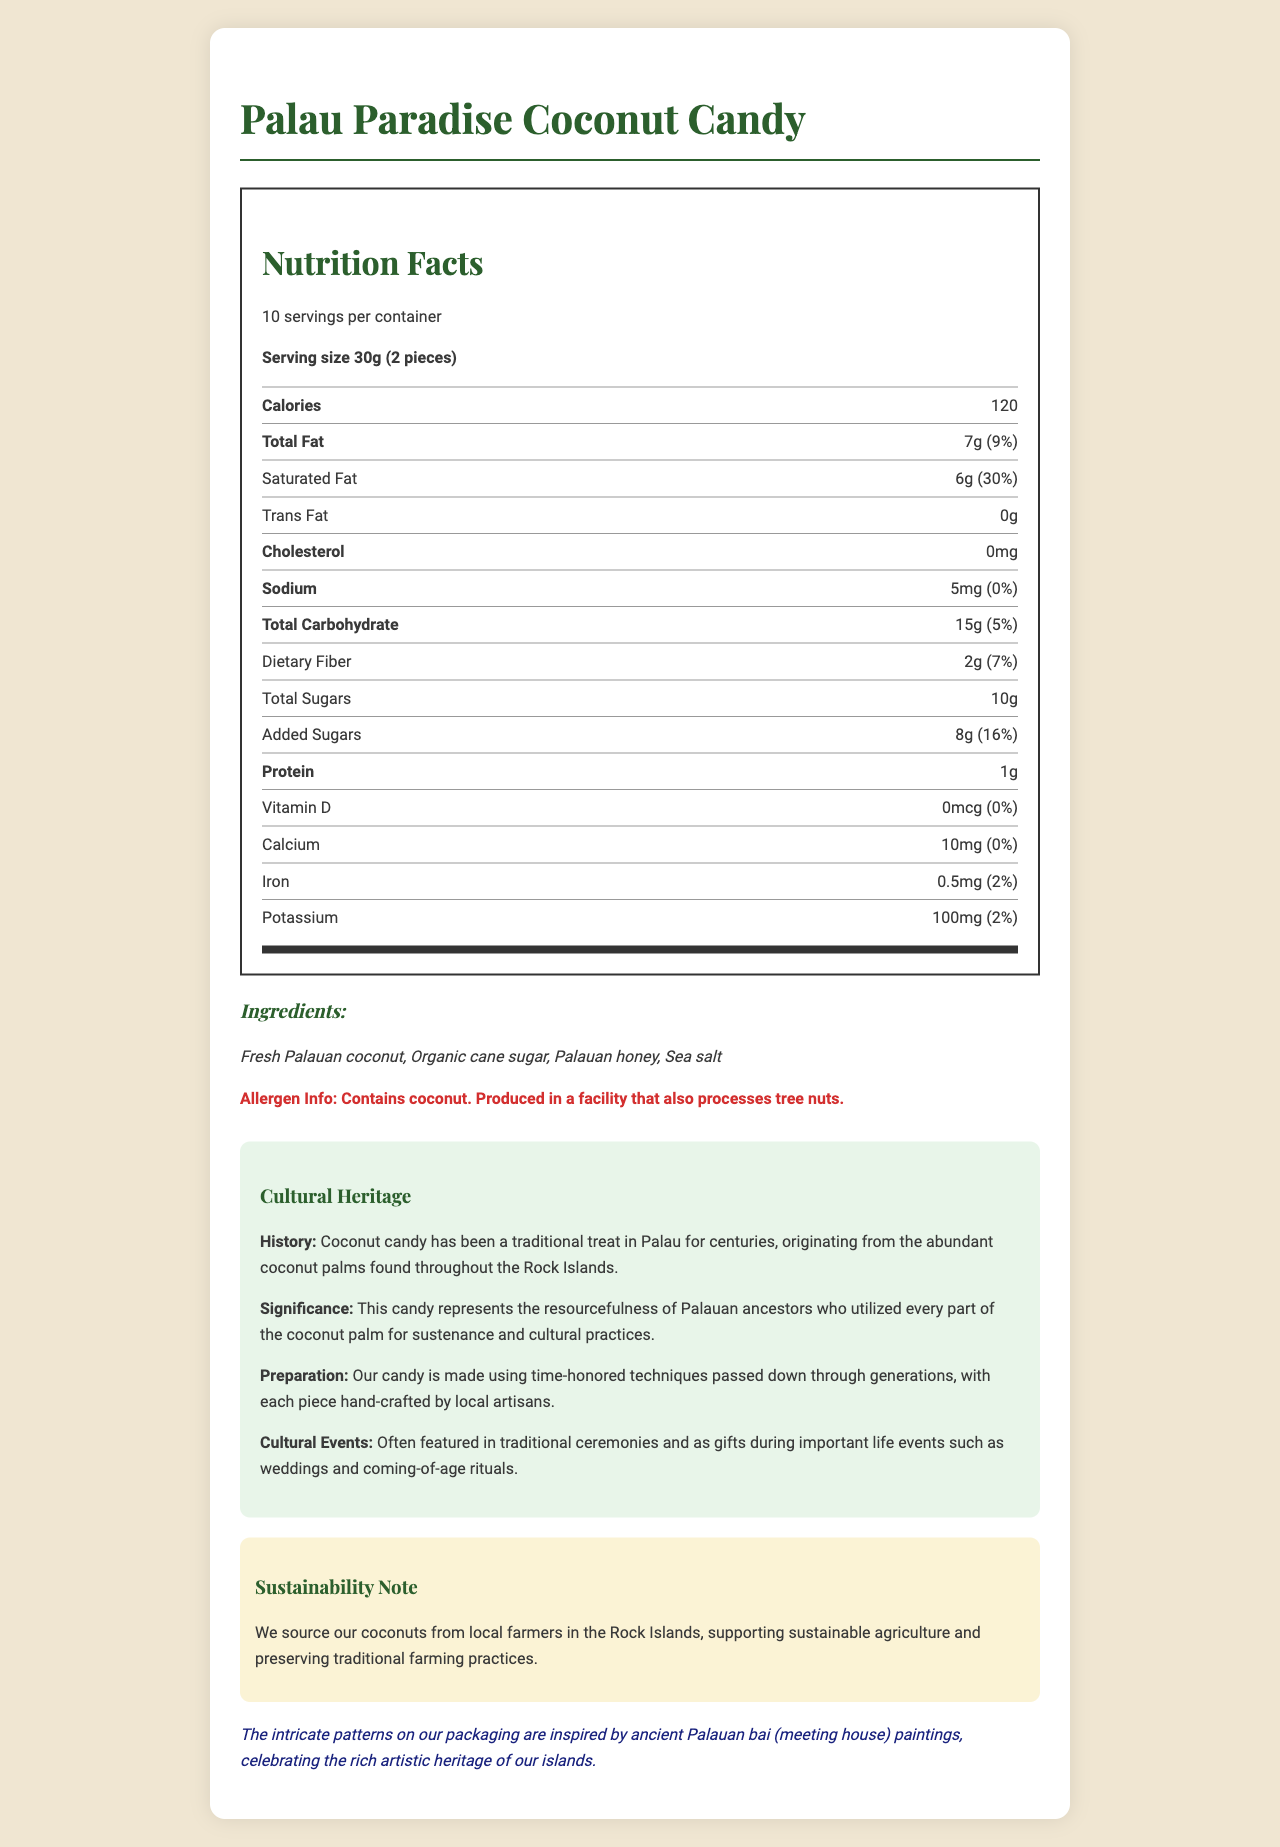what is the serving size of Palau Paradise Coconut Candy? The document specifies that the serving size is 30g, which equals 2 pieces of the candy.
Answer: 30g (2 pieces) how much saturated fat is in one serving? The nutrition label states that one serving contains 6 grams of saturated fat.
Answer: 6g what are the main ingredients in the candy? The ingredients section lists these as the main components of the candy.
Answer: Fresh Palauan coconut, Organic cane sugar, Palauan honey, Sea salt how many calories are in one serving? The nutrition label indicates that each serving contains 120 calories.
Answer: 120 does this candy contain any added sugars? If yes, how much? The label shows that the candy contains 8 grams of added sugars.
Answer: Yes, 8g what is the historical significance of this coconut candy in Palauan culture? The cultural heritage section provides this information about the candy's historical significance.
Answer: Represents the resourcefulness of Palauan ancestors who utilized every part of the coconut palm for sustenance and cultural practices how much protein does one serving contain? According to the nutrition facts, each serving has 1 gram of protein.
Answer: 1g does this product contain vitamin D? The nutrition label states that vitamin D amount is 0mcg, and its daily value is 0%.
Answer: No which allergen is present in this candy? A. Peanuts B. Soy C. Coconut D. Dairy The document mentions that the candy contains coconut.
Answer: C. Coconut how many servings are there per container? A. 5 servings B. 10 servings C. 15 servings D. 20 servings The label specifies that there are 10 servings per container.
Answer: B. 10 servings is there any cholesterol in this candy? The document specifies that the amount of cholesterol is 0mg.
Answer: No who are the local producers involved in making this candy? The document mentions local artisans and farmers but does not provide their specific identities.
Answer: Not enough information summarize the sustainability practices used in producing this candy The document includes a note on sustainability, indicating that local sourcing and sustainability are key practices.
Answer: The candy is made using coconuts sourced from local farmers in the Rock Islands, supporting sustainable agriculture and preserving traditional farming practices. does the packaging have any connection to art? If yes, what is it? The document states that the packaging celebrates the rich artistic heritage of the islands by using designs inspired by ancient Palauan bai paintings.
Answer: Yes, the patterns are inspired by ancient Palauan bai (meeting house) paintings when is this coconut candy often featured? The cultural heritage section mentions these events.
Answer: Traditional ceremonies and important life events such as weddings and coming-of-age rituals 